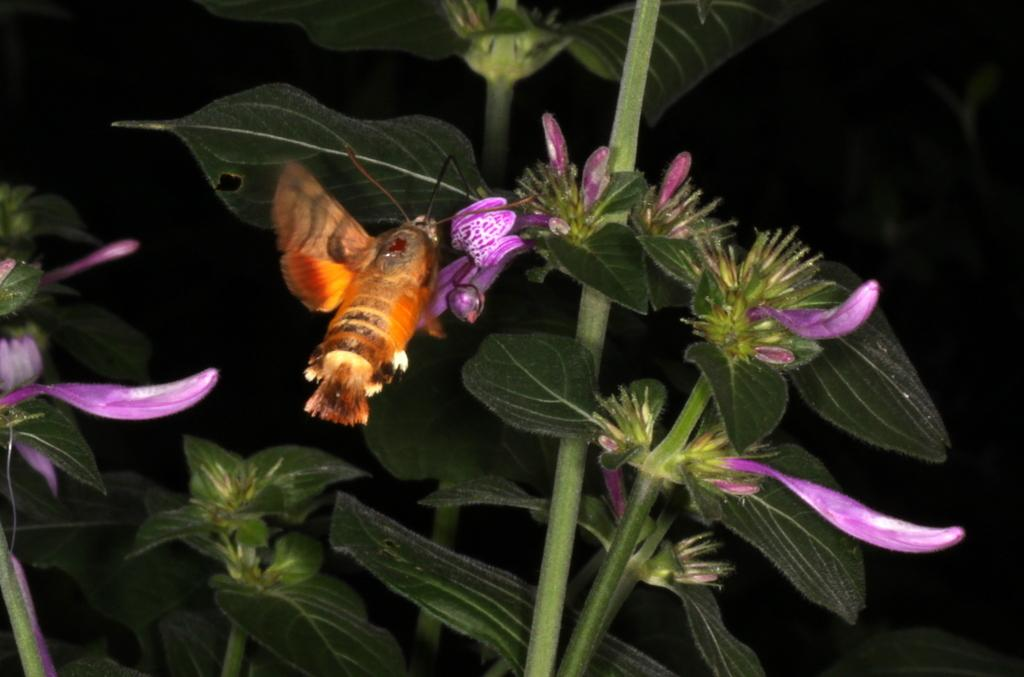What is present in the image? There is an insect in the image. Where is the insect located? The insect is on a tree. What can be observed about the background of the image? The background of the image is dark. What type of protest is happening in the image? There is no protest present in the image; it features an insect on a tree with a dark background. Who is teaching in the image? There is no teaching or teacher present in the image. 